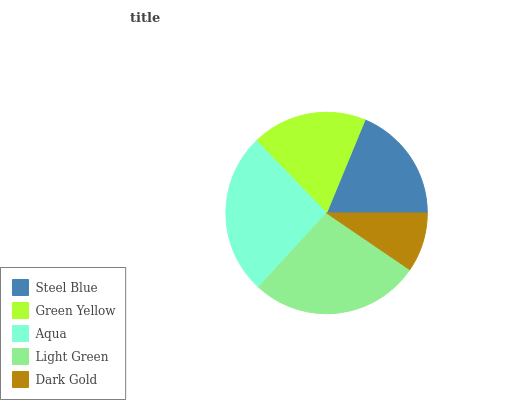Is Dark Gold the minimum?
Answer yes or no. Yes. Is Light Green the maximum?
Answer yes or no. Yes. Is Green Yellow the minimum?
Answer yes or no. No. Is Green Yellow the maximum?
Answer yes or no. No. Is Steel Blue greater than Green Yellow?
Answer yes or no. Yes. Is Green Yellow less than Steel Blue?
Answer yes or no. Yes. Is Green Yellow greater than Steel Blue?
Answer yes or no. No. Is Steel Blue less than Green Yellow?
Answer yes or no. No. Is Steel Blue the high median?
Answer yes or no. Yes. Is Steel Blue the low median?
Answer yes or no. Yes. Is Aqua the high median?
Answer yes or no. No. Is Dark Gold the low median?
Answer yes or no. No. 